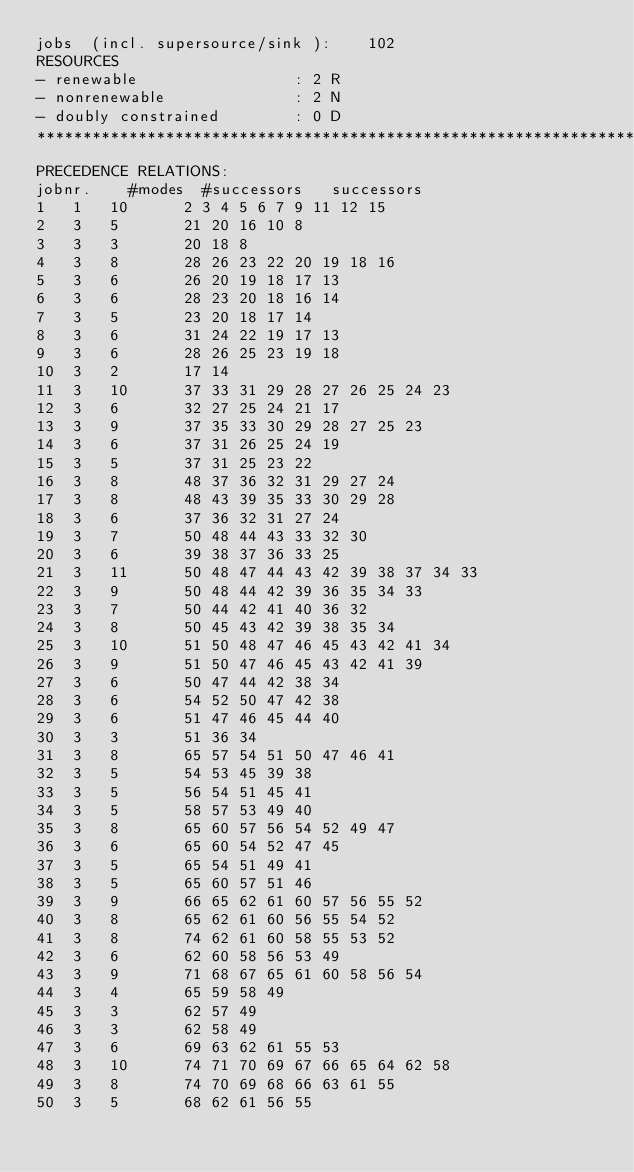Convert code to text. <code><loc_0><loc_0><loc_500><loc_500><_ObjectiveC_>jobs  (incl. supersource/sink ):	102
RESOURCES
- renewable                 : 2 R
- nonrenewable              : 2 N
- doubly constrained        : 0 D
************************************************************************
PRECEDENCE RELATIONS:
jobnr.    #modes  #successors   successors
1	1	10		2 3 4 5 6 7 9 11 12 15 
2	3	5		21 20 16 10 8 
3	3	3		20 18 8 
4	3	8		28 26 23 22 20 19 18 16 
5	3	6		26 20 19 18 17 13 
6	3	6		28 23 20 18 16 14 
7	3	5		23 20 18 17 14 
8	3	6		31 24 22 19 17 13 
9	3	6		28 26 25 23 19 18 
10	3	2		17 14 
11	3	10		37 33 31 29 28 27 26 25 24 23 
12	3	6		32 27 25 24 21 17 
13	3	9		37 35 33 30 29 28 27 25 23 
14	3	6		37 31 26 25 24 19 
15	3	5		37 31 25 23 22 
16	3	8		48 37 36 32 31 29 27 24 
17	3	8		48 43 39 35 33 30 29 28 
18	3	6		37 36 32 31 27 24 
19	3	7		50 48 44 43 33 32 30 
20	3	6		39 38 37 36 33 25 
21	3	11		50 48 47 44 43 42 39 38 37 34 33 
22	3	9		50 48 44 42 39 36 35 34 33 
23	3	7		50 44 42 41 40 36 32 
24	3	8		50 45 43 42 39 38 35 34 
25	3	10		51 50 48 47 46 45 43 42 41 34 
26	3	9		51 50 47 46 45 43 42 41 39 
27	3	6		50 47 44 42 38 34 
28	3	6		54 52 50 47 42 38 
29	3	6		51 47 46 45 44 40 
30	3	3		51 36 34 
31	3	8		65 57 54 51 50 47 46 41 
32	3	5		54 53 45 39 38 
33	3	5		56 54 51 45 41 
34	3	5		58 57 53 49 40 
35	3	8		65 60 57 56 54 52 49 47 
36	3	6		65 60 54 52 47 45 
37	3	5		65 54 51 49 41 
38	3	5		65 60 57 51 46 
39	3	9		66 65 62 61 60 57 56 55 52 
40	3	8		65 62 61 60 56 55 54 52 
41	3	8		74 62 61 60 58 55 53 52 
42	3	6		62 60 58 56 53 49 
43	3	9		71 68 67 65 61 60 58 56 54 
44	3	4		65 59 58 49 
45	3	3		62 57 49 
46	3	3		62 58 49 
47	3	6		69 63 62 61 55 53 
48	3	10		74 71 70 69 67 66 65 64 62 58 
49	3	8		74 70 69 68 66 63 61 55 
50	3	5		68 62 61 56 55 </code> 